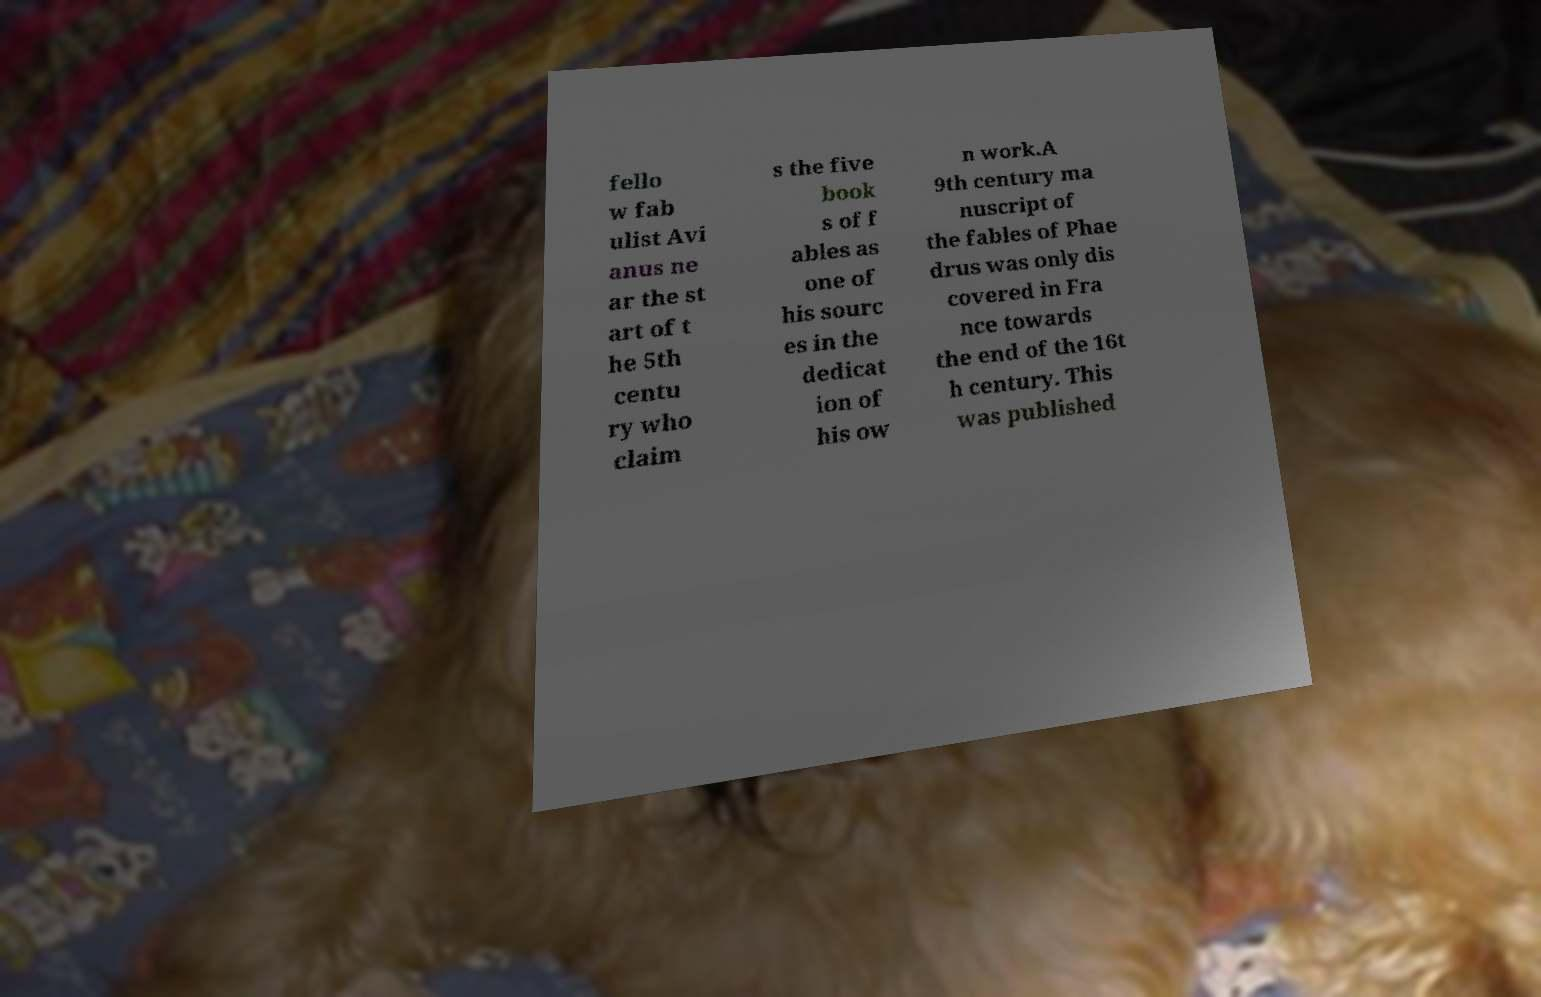I need the written content from this picture converted into text. Can you do that? fello w fab ulist Avi anus ne ar the st art of t he 5th centu ry who claim s the five book s of f ables as one of his sourc es in the dedicat ion of his ow n work.A 9th century ma nuscript of the fables of Phae drus was only dis covered in Fra nce towards the end of the 16t h century. This was published 